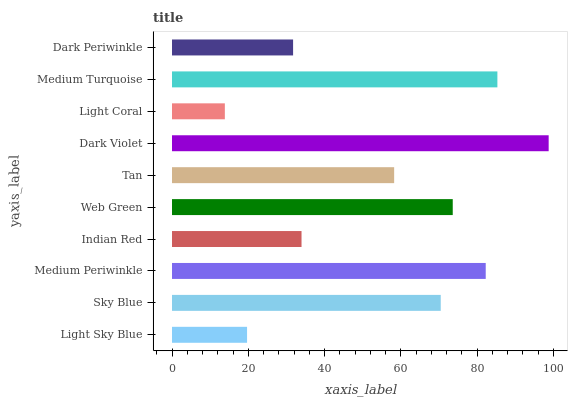Is Light Coral the minimum?
Answer yes or no. Yes. Is Dark Violet the maximum?
Answer yes or no. Yes. Is Sky Blue the minimum?
Answer yes or no. No. Is Sky Blue the maximum?
Answer yes or no. No. Is Sky Blue greater than Light Sky Blue?
Answer yes or no. Yes. Is Light Sky Blue less than Sky Blue?
Answer yes or no. Yes. Is Light Sky Blue greater than Sky Blue?
Answer yes or no. No. Is Sky Blue less than Light Sky Blue?
Answer yes or no. No. Is Sky Blue the high median?
Answer yes or no. Yes. Is Tan the low median?
Answer yes or no. Yes. Is Medium Turquoise the high median?
Answer yes or no. No. Is Medium Turquoise the low median?
Answer yes or no. No. 